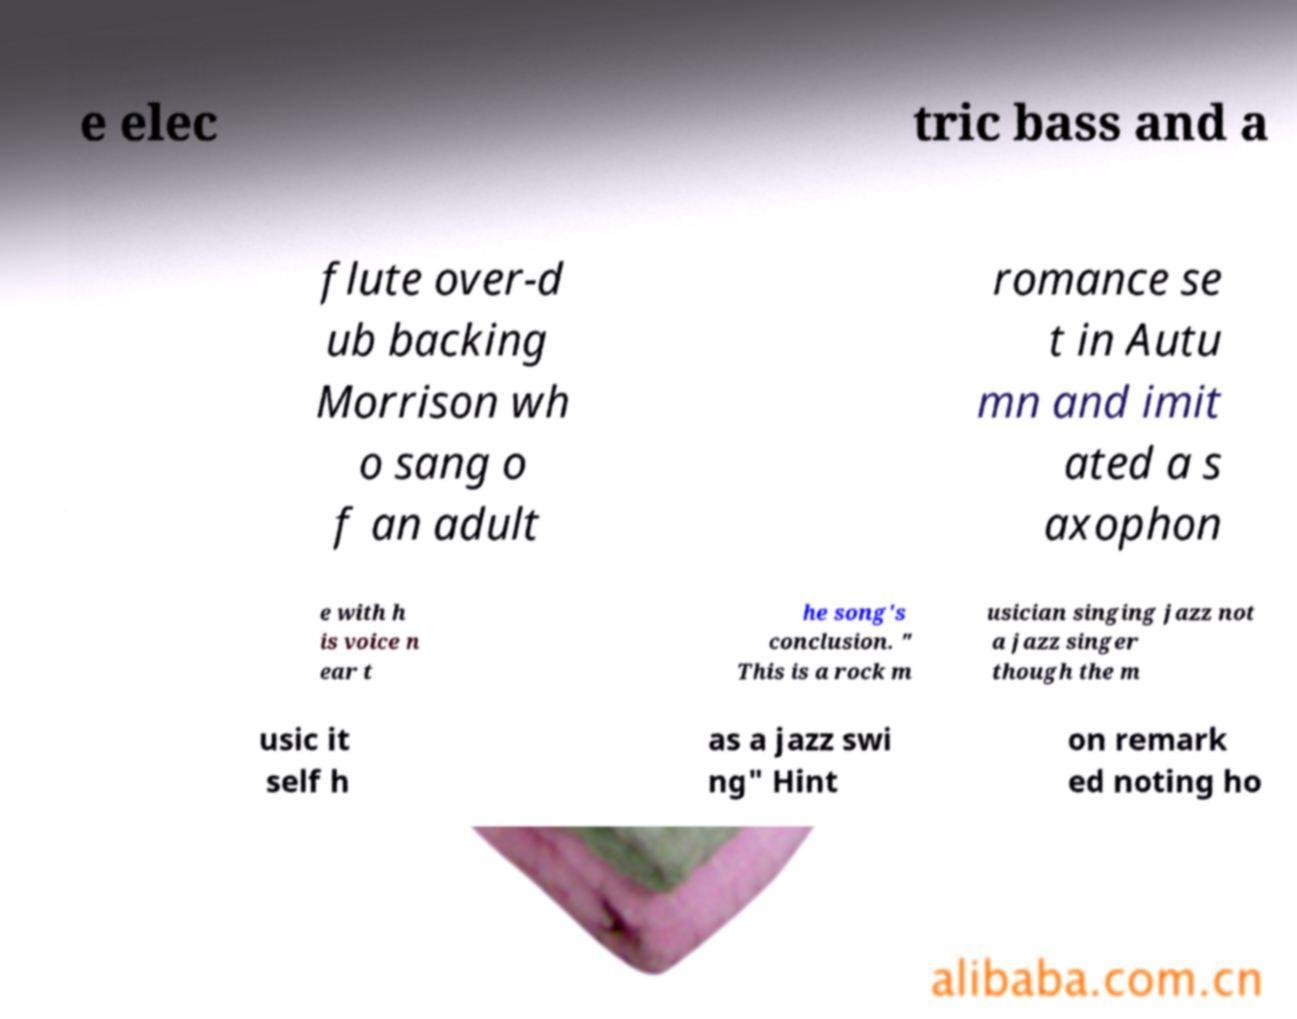There's text embedded in this image that I need extracted. Can you transcribe it verbatim? e elec tric bass and a flute over-d ub backing Morrison wh o sang o f an adult romance se t in Autu mn and imit ated a s axophon e with h is voice n ear t he song's conclusion. " This is a rock m usician singing jazz not a jazz singer though the m usic it self h as a jazz swi ng" Hint on remark ed noting ho 